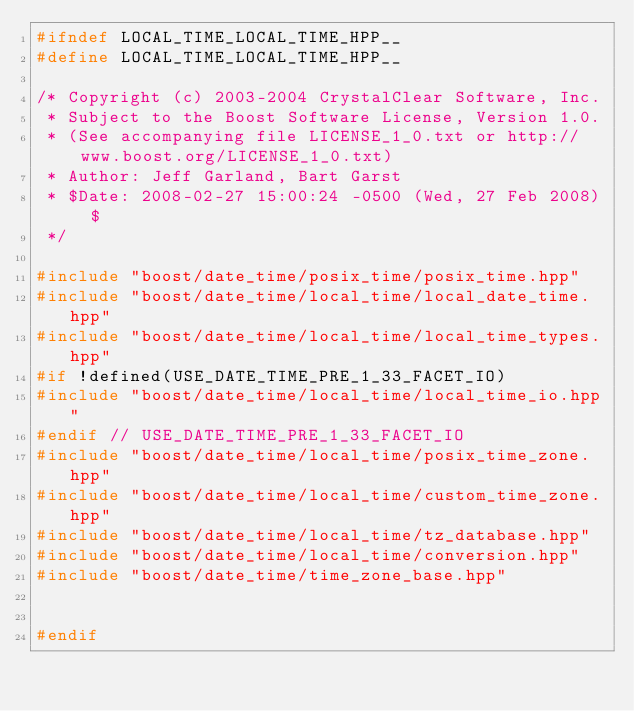<code> <loc_0><loc_0><loc_500><loc_500><_C++_>#ifndef LOCAL_TIME_LOCAL_TIME_HPP__
#define LOCAL_TIME_LOCAL_TIME_HPP__

/* Copyright (c) 2003-2004 CrystalClear Software, Inc.
 * Subject to the Boost Software License, Version 1.0. 
 * (See accompanying file LICENSE_1_0.txt or http://www.boost.org/LICENSE_1_0.txt)
 * Author: Jeff Garland, Bart Garst
 * $Date: 2008-02-27 15:00:24 -0500 (Wed, 27 Feb 2008) $
 */

#include "boost/date_time/posix_time/posix_time.hpp"
#include "boost/date_time/local_time/local_date_time.hpp"
#include "boost/date_time/local_time/local_time_types.hpp"
#if !defined(USE_DATE_TIME_PRE_1_33_FACET_IO)
#include "boost/date_time/local_time/local_time_io.hpp"
#endif // USE_DATE_TIME_PRE_1_33_FACET_IO
#include "boost/date_time/local_time/posix_time_zone.hpp"
#include "boost/date_time/local_time/custom_time_zone.hpp"
#include "boost/date_time/local_time/tz_database.hpp"
#include "boost/date_time/local_time/conversion.hpp"
#include "boost/date_time/time_zone_base.hpp"


#endif
</code> 